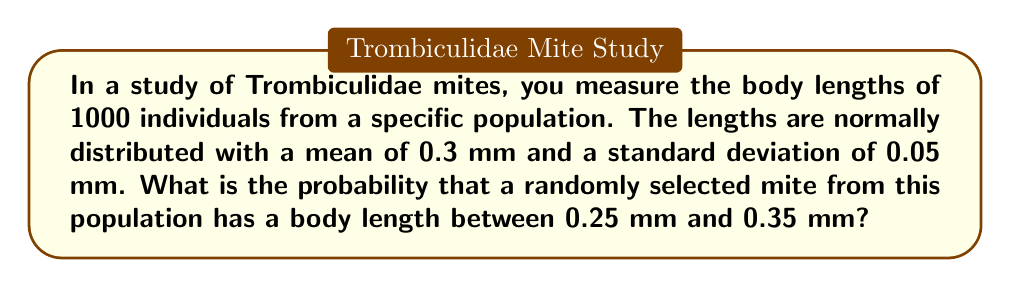Show me your answer to this math problem. To solve this problem, we need to use the properties of the normal distribution and the concept of z-scores.

Step 1: Identify the given information
- The mite body lengths are normally distributed
- Mean (μ) = 0.3 mm
- Standard deviation (σ) = 0.05 mm
- We want to find P(0.25 < X < 0.35), where X is the body length

Step 2: Calculate the z-scores for the lower and upper bounds
For the lower bound: $z_1 = \frac{0.25 - 0.3}{0.05} = -1$
For the upper bound: $z_2 = \frac{0.35 - 0.3}{0.05} = 1$

Step 3: Use the standard normal distribution table or calculator to find the area between these z-scores
The probability is equal to the area under the standard normal curve between z = -1 and z = 1.

P(-1 < Z < 1) = P(Z < 1) - P(Z < -1)
              = 0.8413 - 0.1587
              = 0.6826

Step 4: Convert the result to a percentage
0.6826 * 100 = 68.26%

Therefore, the probability that a randomly selected mite from this population has a body length between 0.25 mm and 0.35 mm is approximately 68.26%.
Answer: 68.26% 